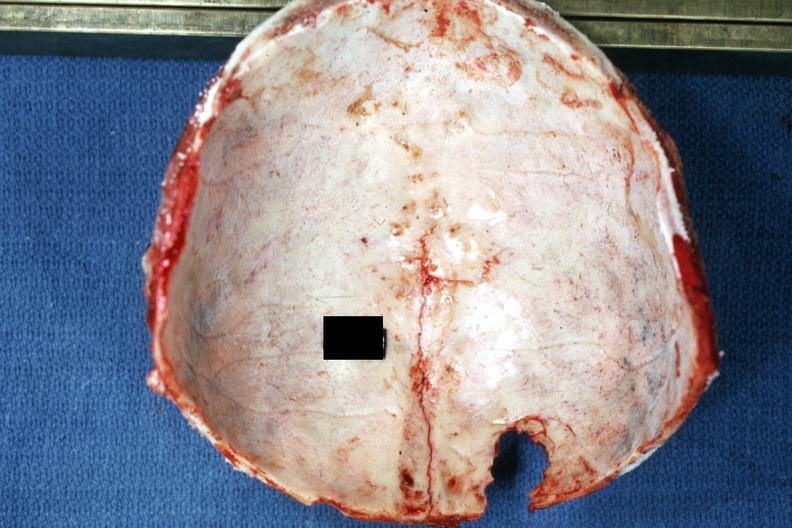does this image show easily seen lesion extending up midline to vertex?
Answer the question using a single word or phrase. Yes 